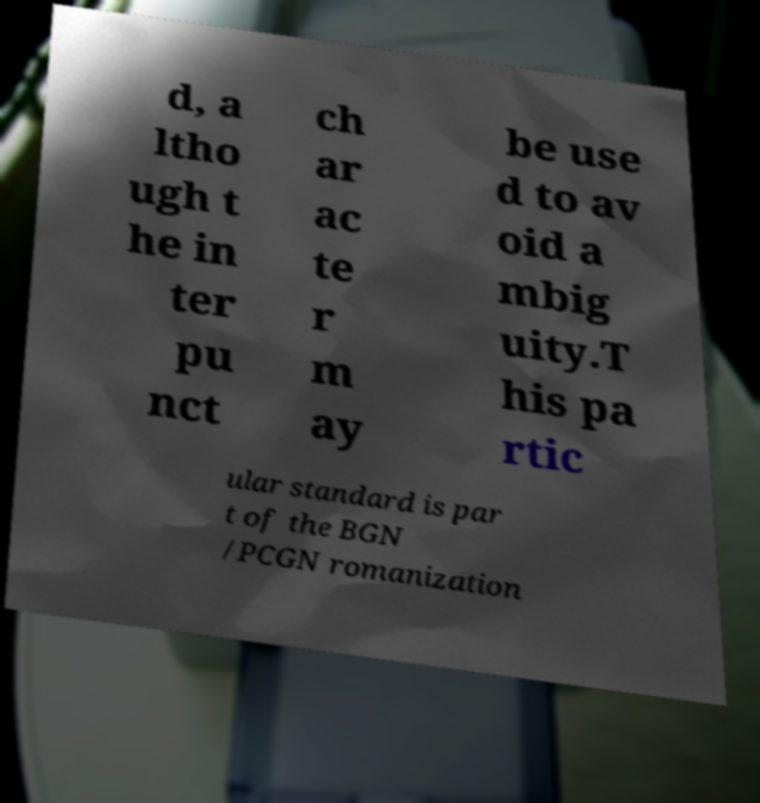Please identify and transcribe the text found in this image. d, a ltho ugh t he in ter pu nct ch ar ac te r m ay be use d to av oid a mbig uity.T his pa rtic ular standard is par t of the BGN /PCGN romanization 